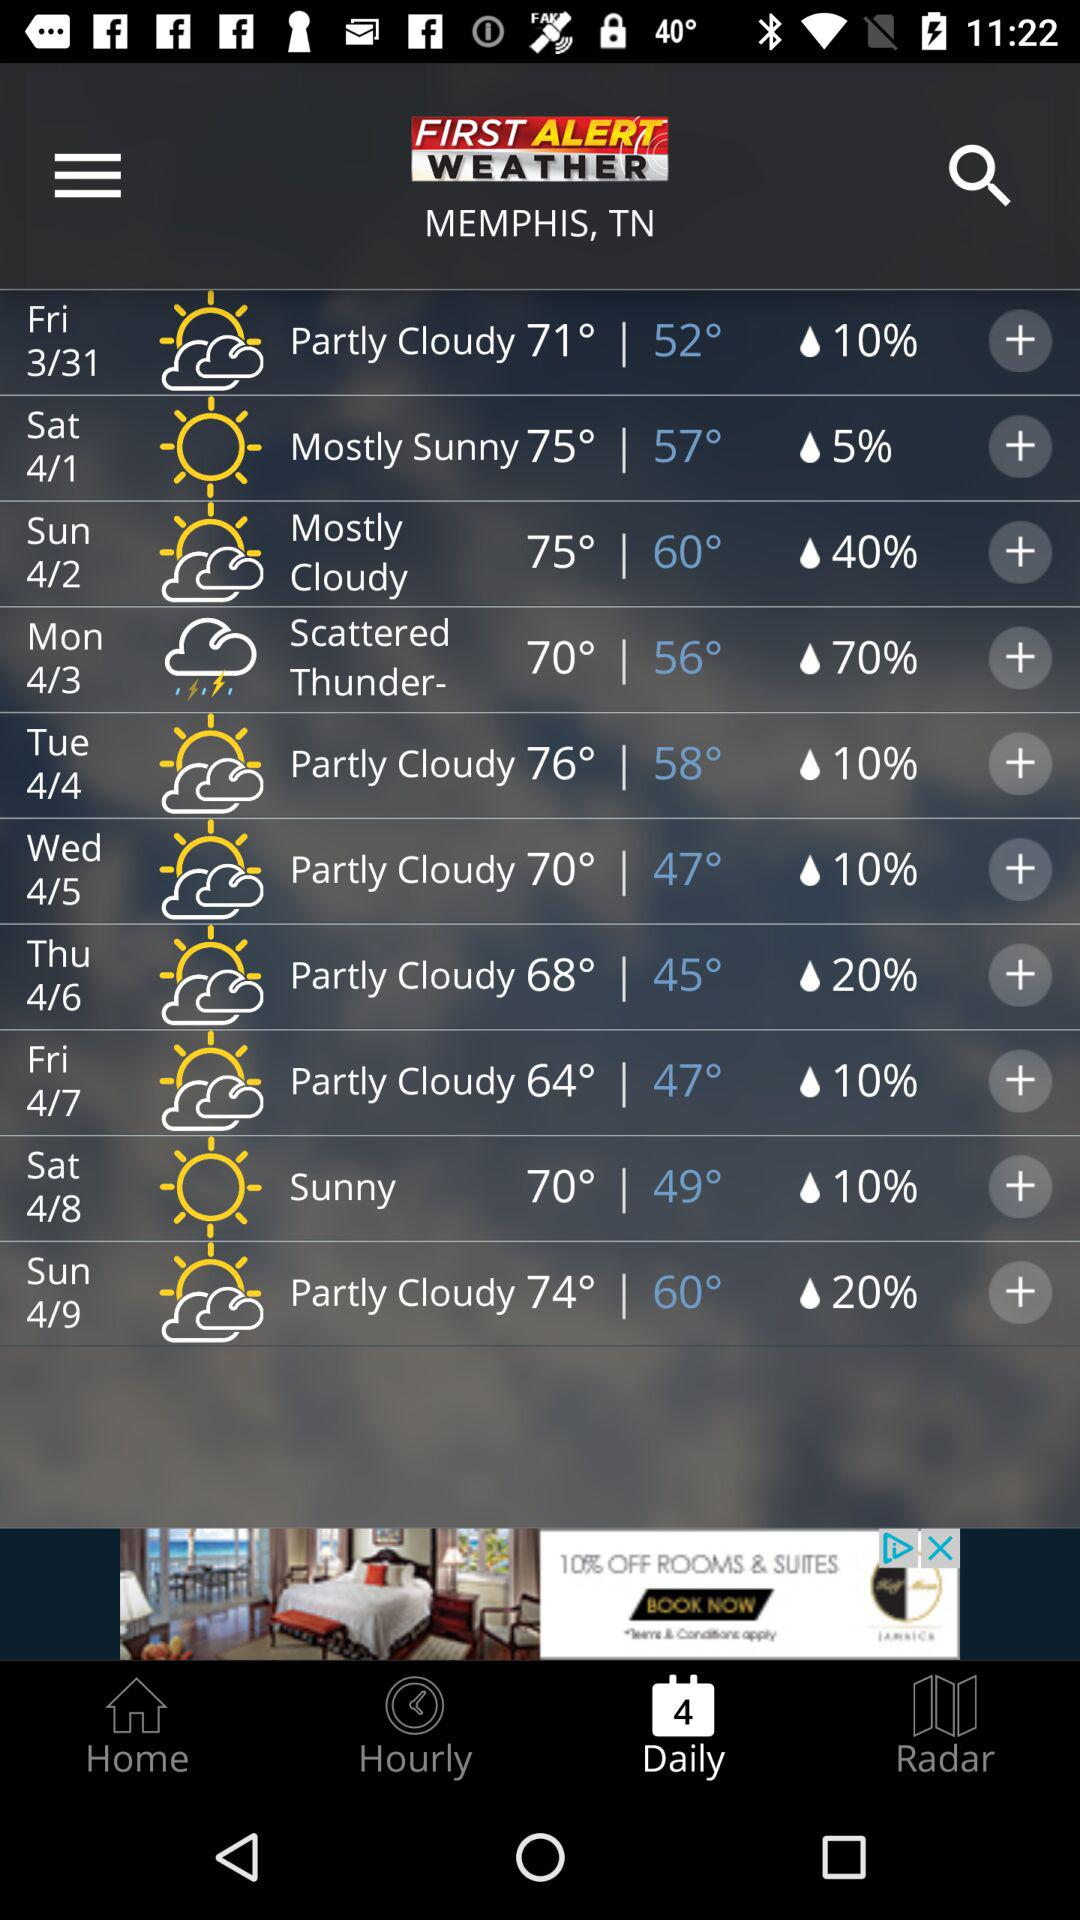What is the lowest temperature in the forecast?
Answer the question using a single word or phrase. 45° 